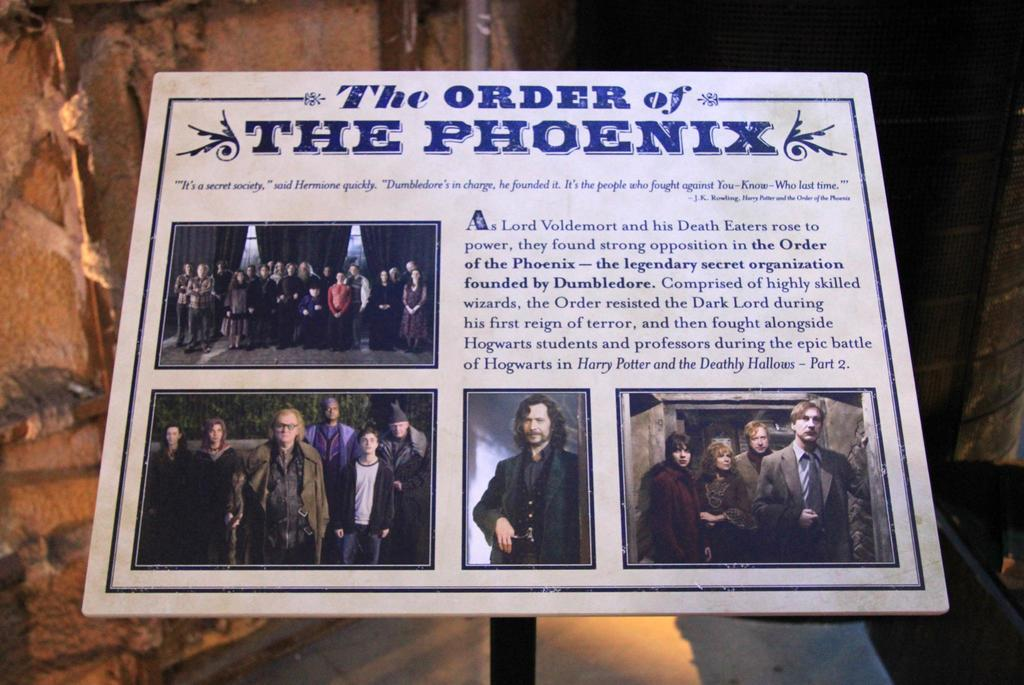<image>
Create a compact narrative representing the image presented. the order of the phoenix poster advertise a play 